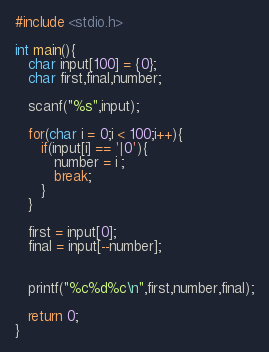<code> <loc_0><loc_0><loc_500><loc_500><_C_>#include <stdio.h>

int main(){
   char input[100] = {0};
   char first,final,number;

   scanf("%s",input);

   for(char i = 0;i < 100;i++){
      if(input[i] == '|0'){
         number = i ;
         break;
      }
   }

   first = input[0];
   final = input[--number];


   printf("%c%d%c\n",first,number,final);

   return 0;
}</code> 